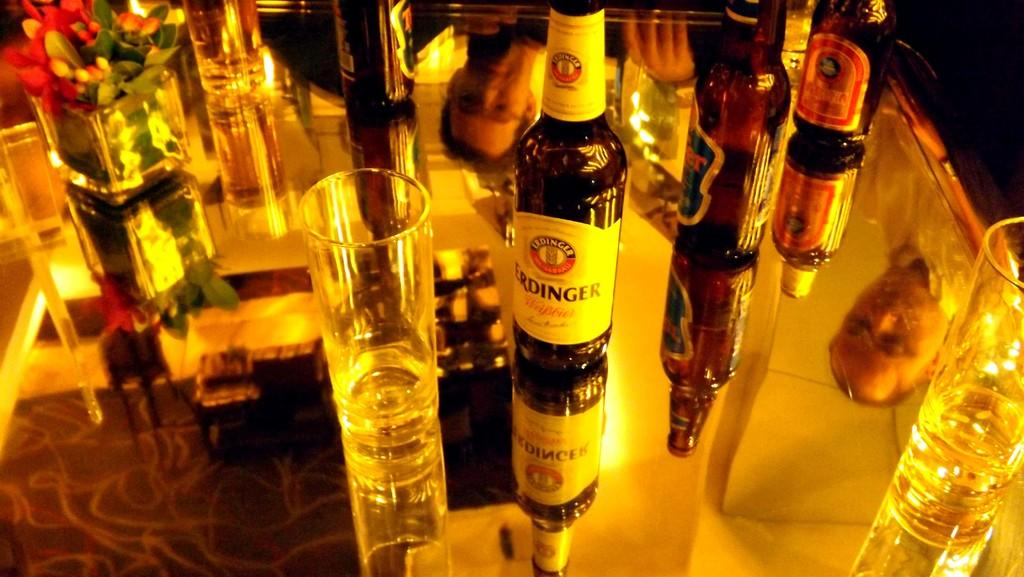Who can be seen in the image through the reflections? There are reflections of two persons in the image. What is the main object in the image? There is a table in the image. What can be found on the table? A glass, bottles, and a flower vase are present on the table. What type of whip is being used by the person in the image? There is no whip present in the image. What date is shown on the calendar in the image? There is no calendar present in the image. 